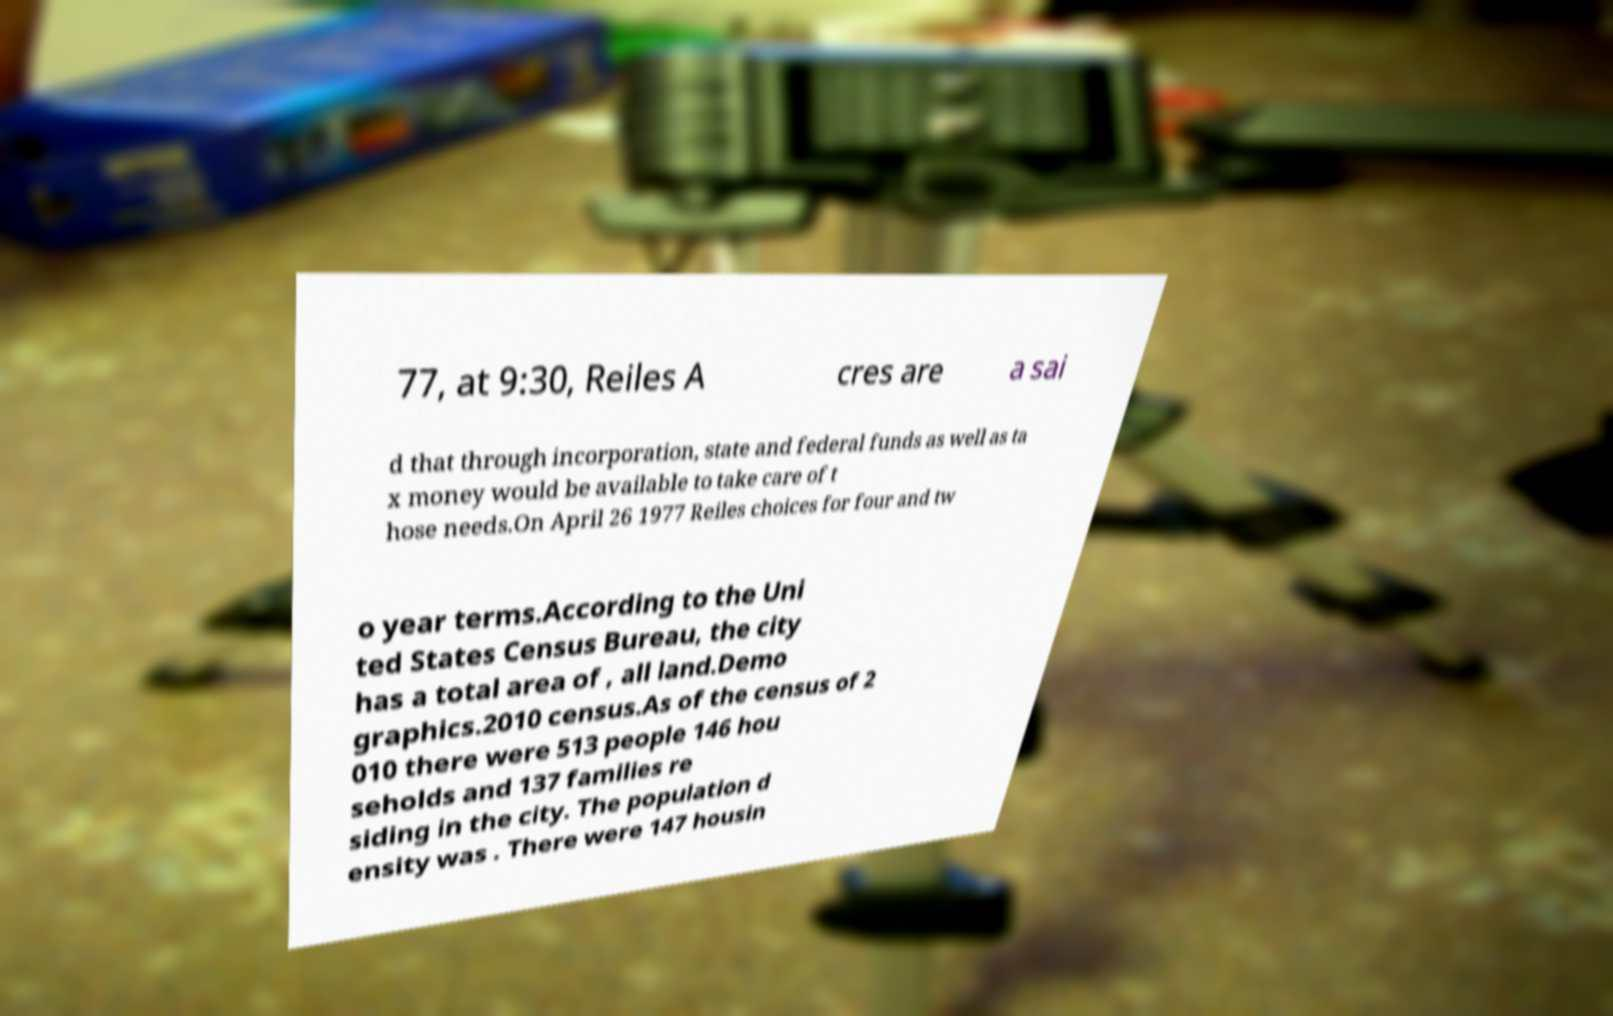I need the written content from this picture converted into text. Can you do that? 77, at 9:30, Reiles A cres are a sai d that through incorporation, state and federal funds as well as ta x money would be available to take care of t hose needs.On April 26 1977 Reiles choices for four and tw o year terms.According to the Uni ted States Census Bureau, the city has a total area of , all land.Demo graphics.2010 census.As of the census of 2 010 there were 513 people 146 hou seholds and 137 families re siding in the city. The population d ensity was . There were 147 housin 